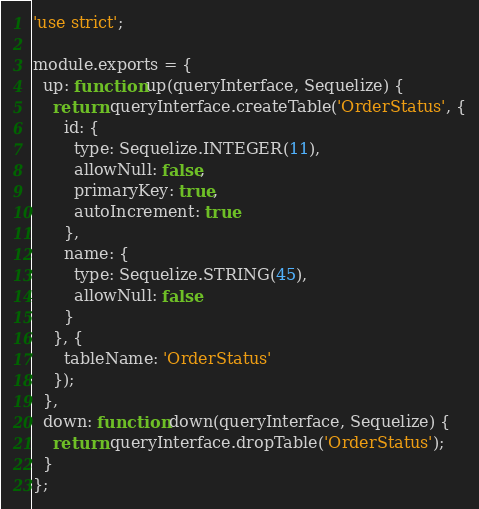<code> <loc_0><loc_0><loc_500><loc_500><_JavaScript_>'use strict';

module.exports = {
  up: function up(queryInterface, Sequelize) {
    return queryInterface.createTable('OrderStatus', {
      id: {
        type: Sequelize.INTEGER(11),
        allowNull: false,
        primaryKey: true,
        autoIncrement: true
      },
      name: {
        type: Sequelize.STRING(45),
        allowNull: false
      }
    }, {
      tableName: 'OrderStatus'
    });
  },
  down: function down(queryInterface, Sequelize) {
    return queryInterface.dropTable('OrderStatus');
  }
};</code> 